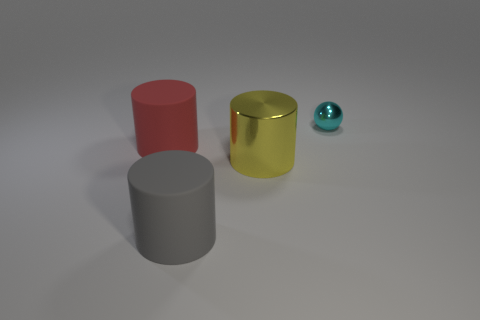Subtract all rubber cylinders. How many cylinders are left? 1 Subtract all cylinders. How many objects are left? 1 Add 3 big rubber cylinders. How many objects exist? 7 Subtract all gray cylinders. How many cylinders are left? 2 Subtract 2 cylinders. How many cylinders are left? 1 Add 4 cyan objects. How many cyan objects are left? 5 Add 4 tiny red metal things. How many tiny red metal things exist? 4 Subtract 0 brown cubes. How many objects are left? 4 Subtract all gray spheres. Subtract all gray cubes. How many spheres are left? 1 Subtract all gray spheres. How many yellow cylinders are left? 1 